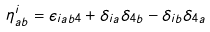<formula> <loc_0><loc_0><loc_500><loc_500>\eta ^ { i } _ { a b } = \epsilon _ { i a b 4 } + \delta _ { i a } \delta _ { 4 b } - \delta _ { i b } \delta _ { 4 a }</formula> 